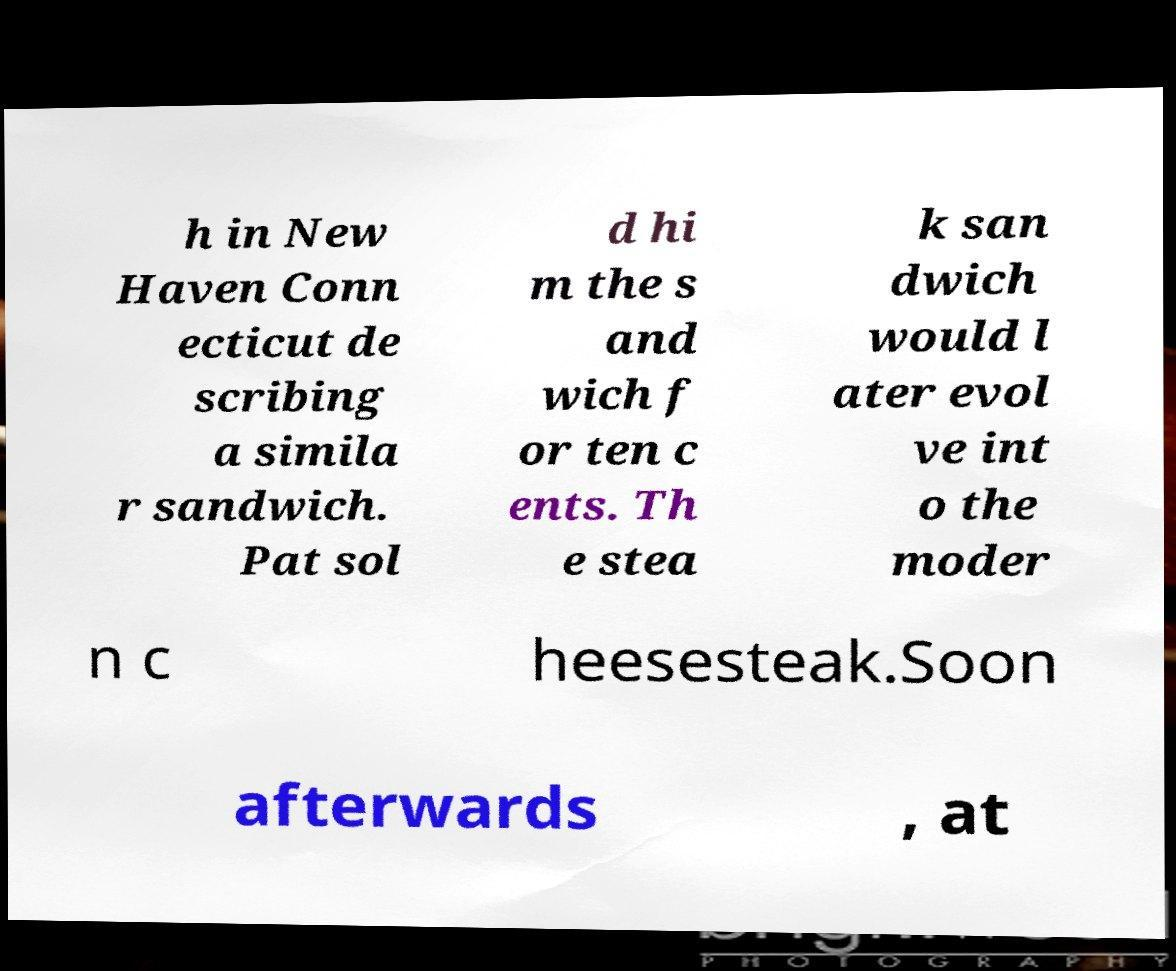For documentation purposes, I need the text within this image transcribed. Could you provide that? h in New Haven Conn ecticut de scribing a simila r sandwich. Pat sol d hi m the s and wich f or ten c ents. Th e stea k san dwich would l ater evol ve int o the moder n c heesesteak.Soon afterwards , at 